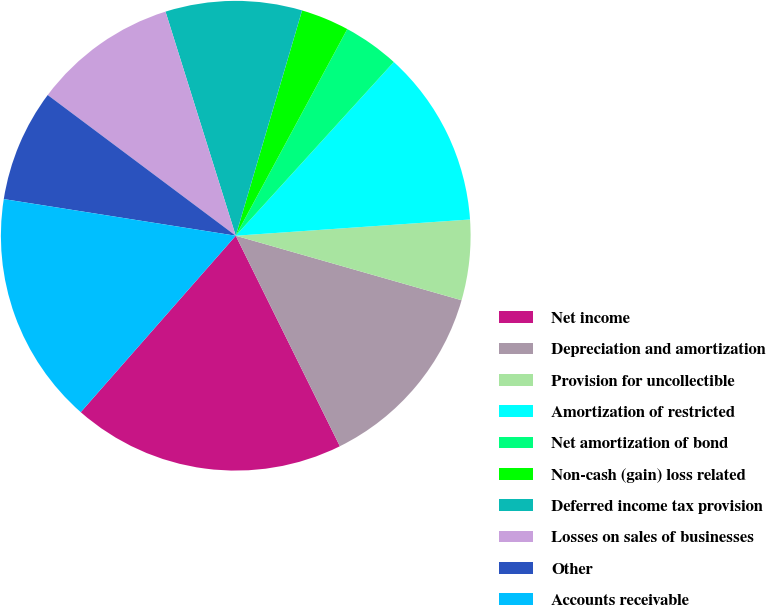<chart> <loc_0><loc_0><loc_500><loc_500><pie_chart><fcel>Net income<fcel>Depreciation and amortization<fcel>Provision for uncollectible<fcel>Amortization of restricted<fcel>Net amortization of bond<fcel>Non-cash (gain) loss related<fcel>Deferred income tax provision<fcel>Losses on sales of businesses<fcel>Other<fcel>Accounts receivable<nl><fcel>18.78%<fcel>13.26%<fcel>5.53%<fcel>12.15%<fcel>3.87%<fcel>3.32%<fcel>9.39%<fcel>9.94%<fcel>7.73%<fcel>16.02%<nl></chart> 